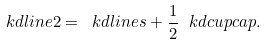<formula> <loc_0><loc_0><loc_500><loc_500>\ k d { l i n e 2 } = \ k d { l i n e s } + \frac { 1 } { 2 } \ k d { c u p c a p } .</formula> 